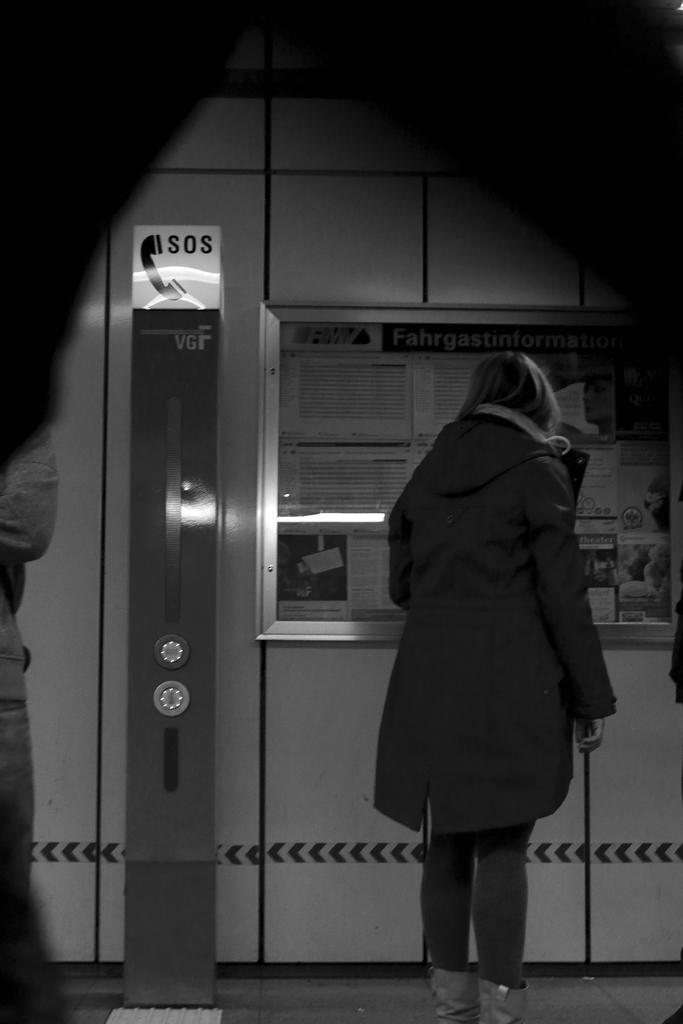<image>
Provide a brief description of the given image. a woman standing next to a sign that says 'sos' 